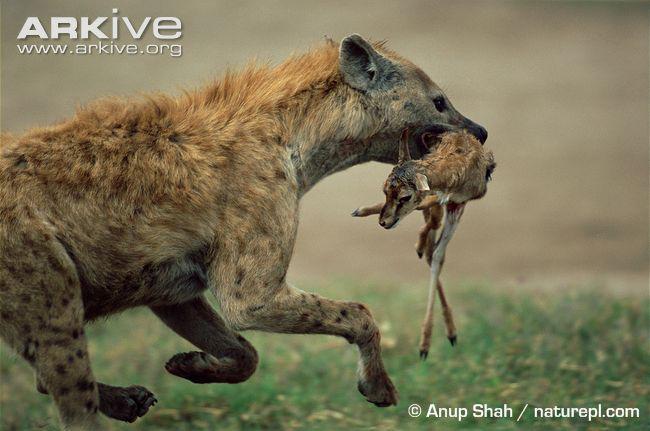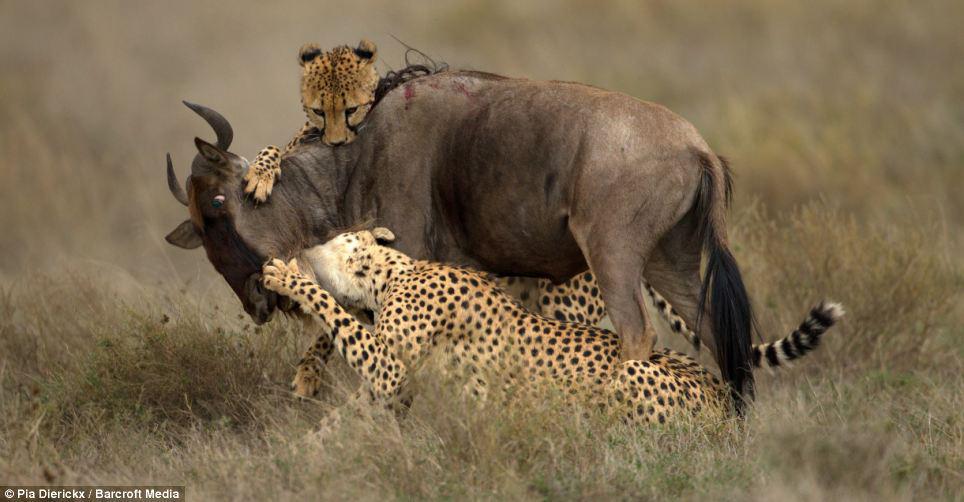The first image is the image on the left, the second image is the image on the right. Given the left and right images, does the statement "The cheetahs are shown with their prey in at least one of the images." hold true? Answer yes or no. Yes. The first image is the image on the left, the second image is the image on the right. Given the left and right images, does the statement "Each image shows a close group of wild cats, and no image shows a prey animal." hold true? Answer yes or no. No. 